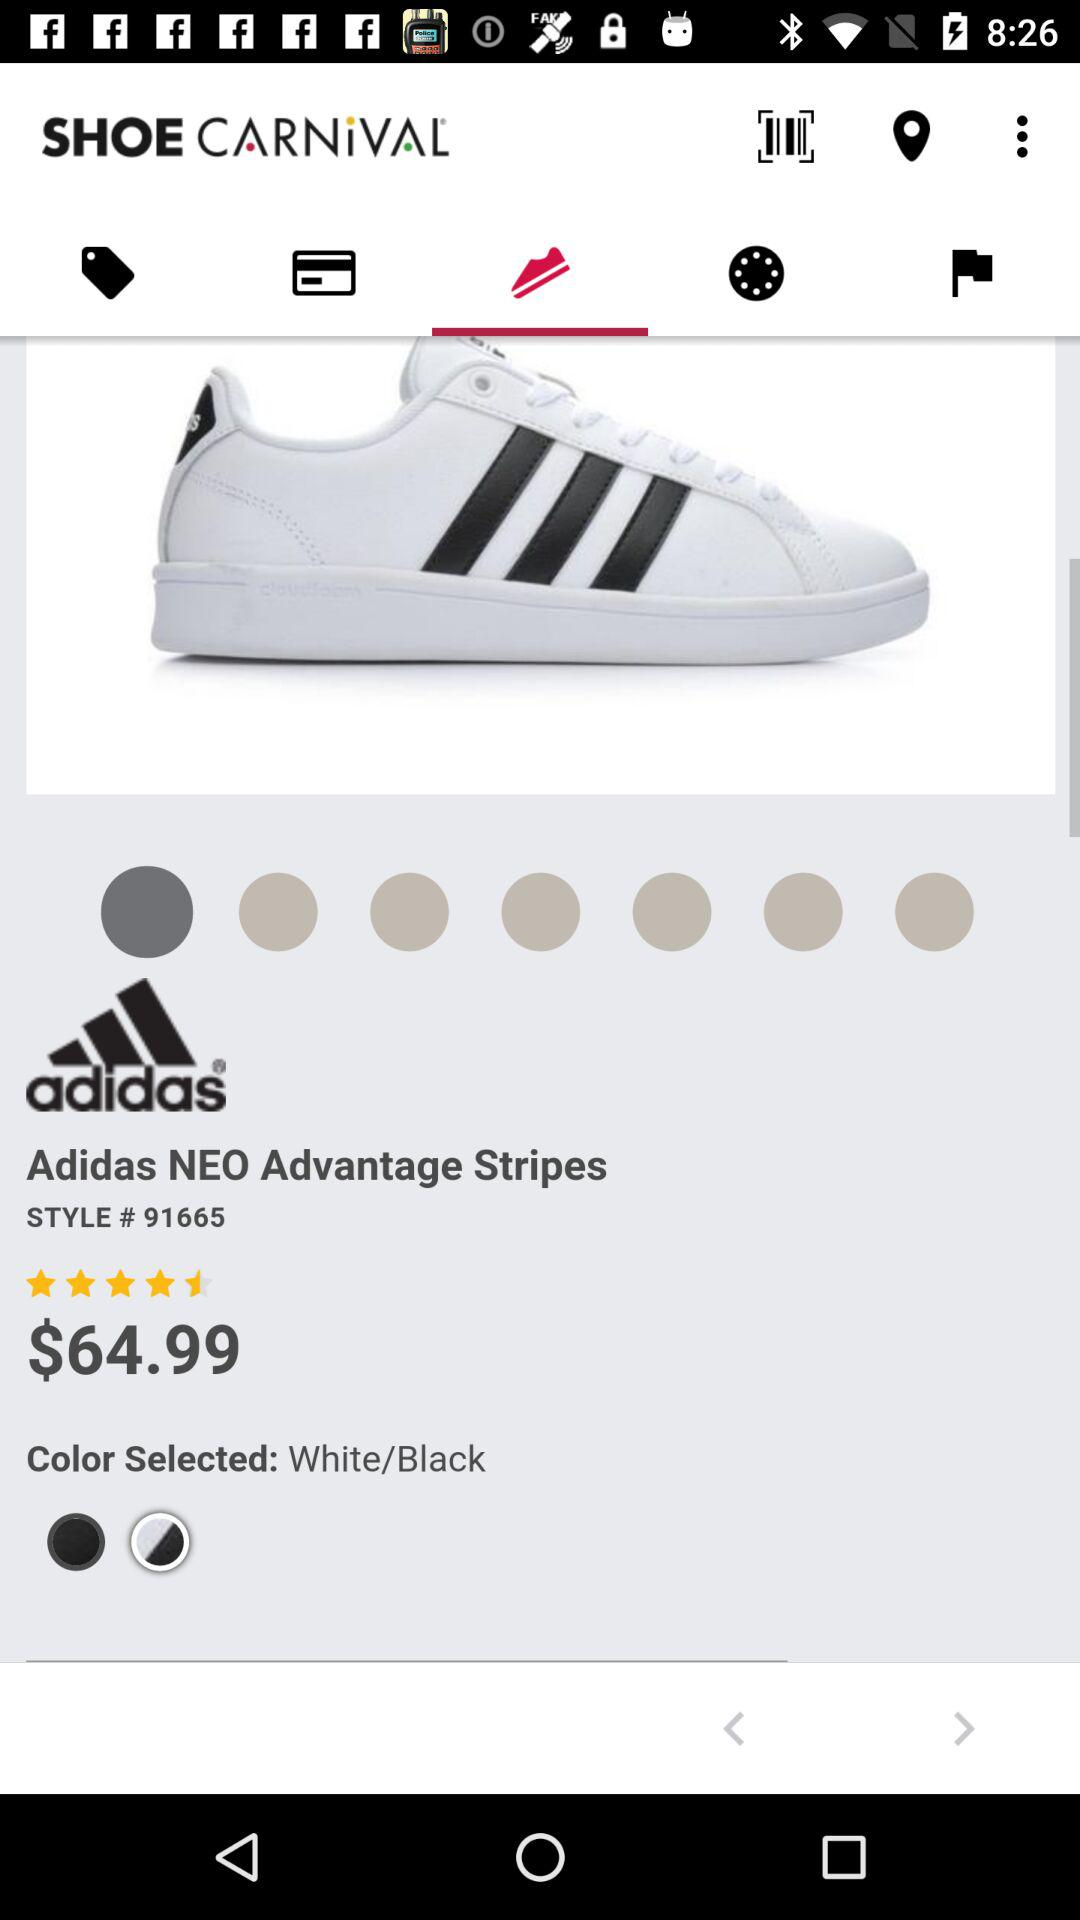What is the selected color of the Adidas NEO Advantage Stripes? The selected color is White/Black. 